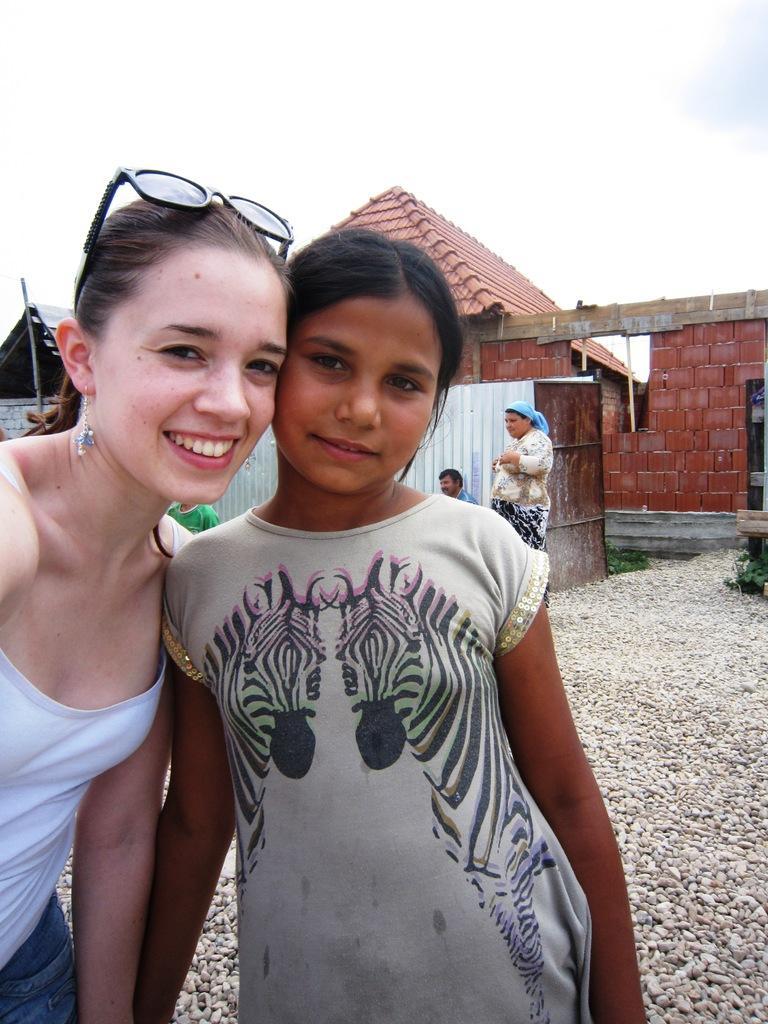In one or two sentences, can you explain what this image depicts? In this image we can see a few people, there are some stones, houses, grass and the wall, in the background, we can see the sky. 